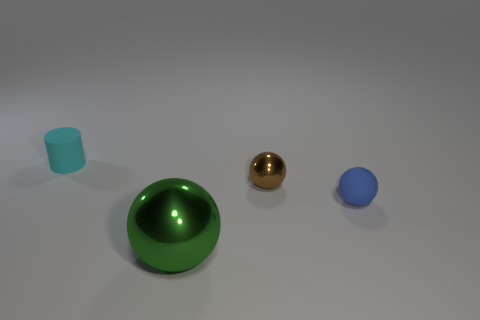What can you tell me about the sizes of the objects relative to each other? The large green sphere is the biggest object in the group, followed by the blue sphere, which is smaller but still sizable. The shiny gold ball is even smaller, and the cyan object is the smallest among them, hinting at a descending order of size from left to right.  Considering their sizes, how might these objects be used together? Given their varying sizes and the simplicity of the scene, they could be used for a visual demonstration of scale or for a lesson in geometry and reflections. They might also represent a set of design elements used in a 3D modeling software tutorial, with a focus on how light interacts with different colored surfaces and materials. 